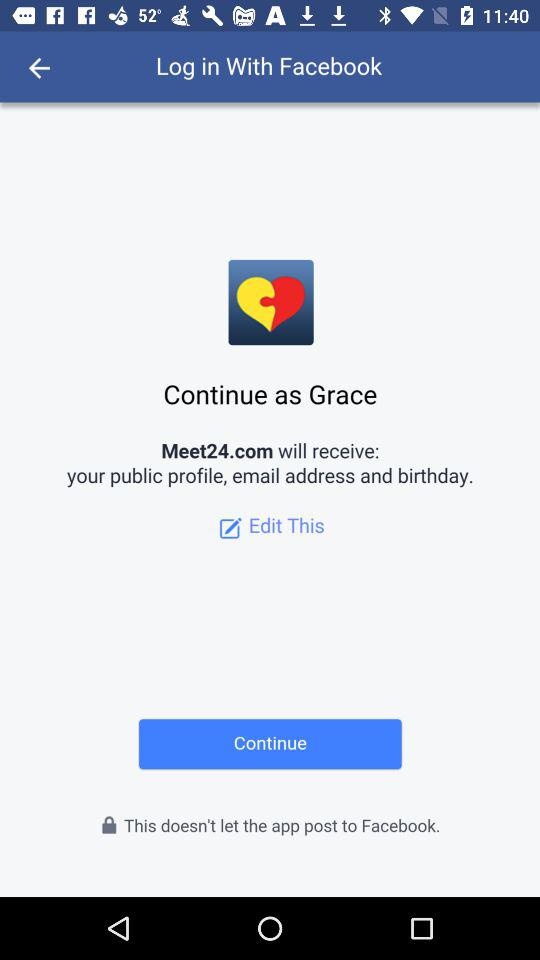How many profile information will Meet24.com receive?
Answer the question using a single word or phrase. 3 